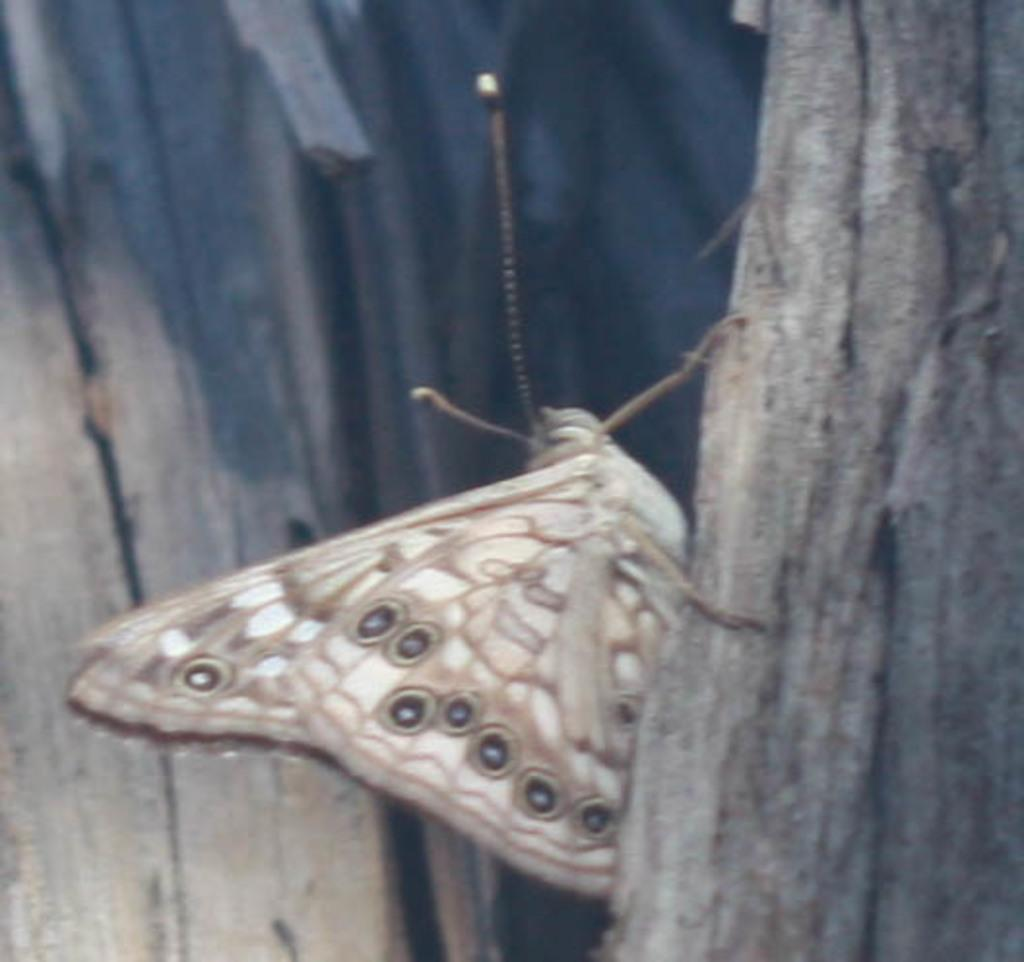What type of objects are made of wood in the image? There are two wooden objects in the image. Can you describe the appearance of the moth in the image? There is a cream-colored moth in the center of the image. How many cakes are being held by the daughter in the image? There is no daughter or cakes present in the image. What type of wire is used to hold the moth in the image? There is no wire present in the image; the moth is simply resting in the center. 